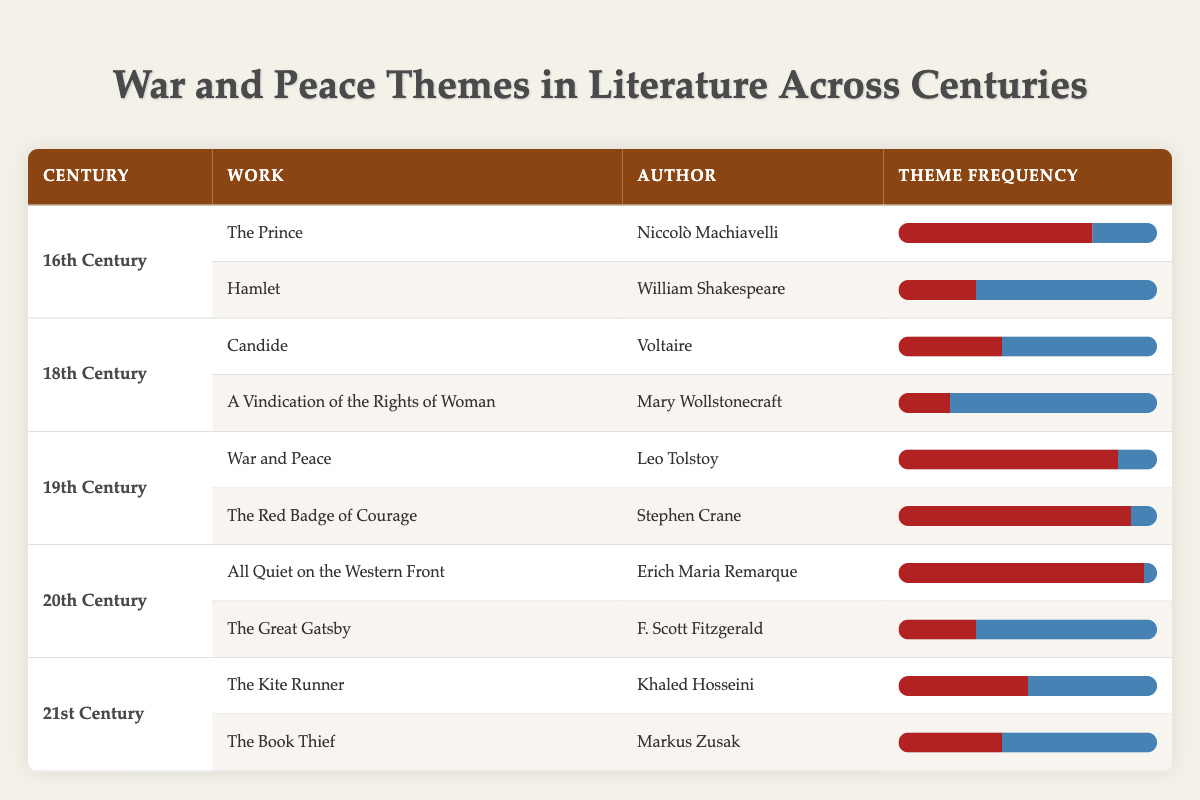What is the total frequency of the war theme in the 19th Century key works? The two key works in the 19th Century are "War and Peace" and "The Red Badge of Courage." The war frequencies for these works are 85 and 90, respectively. Adding these together gives 85 + 90 = 175.
Answer: 175 Which author has the highest frequency of the war theme in their work? The works with the highest war frequency in the table are "All Quiet on the Western Front" by Erich Maria Remarque with a frequency of 95, and "The Red Badge of Courage" by Stephen Crane with a frequency of 90. Since 95 is higher than 90, Erich Maria Remarque has the highest frequency of the war theme.
Answer: Erich Maria Remarque Is the theme of peace more prevalent in the 21st Century compared to the 19th Century? In the 21st Century, the peace frequencies are 50 and 60 for "The Kite Runner" and "The Book Thief," giving a total of 50 + 60 = 110. In the 19th Century, the peace frequencies for "War and Peace" and "The Red Badge of Courage" are 15 and 10, giving a total of 15 + 10 = 25. Since 110 is greater than 25, peace is more prevalent in the 21st Century.
Answer: Yes What is the average frequency of the war theme in the 18th Century? The war frequencies in the 18th Century are 40 for "Candide" and 20 for "A Vindication of the Rights of Woman." To find the average, we sum these numbers: 40 + 20 = 60, then divide by the number of works, which is 2. Therefore, 60 / 2 = 30.
Answer: 30 Do all authors in the 20th Century focus more on war than peace in their works? In the 20th Century, "All Quiet on the Western Front" has a war frequency of 95 and a peace frequency of 5, indicating a focus on war. "The Great Gatsby" has a war frequency of 30 and a peace frequency of 70, indicating a focus on peace. Since one work's focus is more on peace, not all authors in the 20th Century focus more on war.
Answer: No Which century produced the highest percentage of war themes based on the total frequency of each theme? To determine this, we sum the war frequencies for each century: 75 + 30 = 105 for the 16th, 40 + 20 = 60 for the 18th, 85 + 90 = 175 for the 19th, 95 + 30 = 125 for the 20th, and 50 + 40 = 90 for the 21st century. The highest total is 175 from the 19th Century. The percentage of war themes is (175)/(175 + 15) = 175/190 ≈ 92.1%. Therefore, the 19th century produced the highest percentage of war themes.
Answer: 19th Century What proportion of works in the 16th Century prioritize peace over war? In the 16th Century, there are two works: "The Prince" focuses on war (75) and "Hamlet" focuses on peace (70). Since "Hamlet" is the only work prioritizing peace, the proportion is 1 out of 2 works, which is 1/2 or 50%.
Answer: 50% 